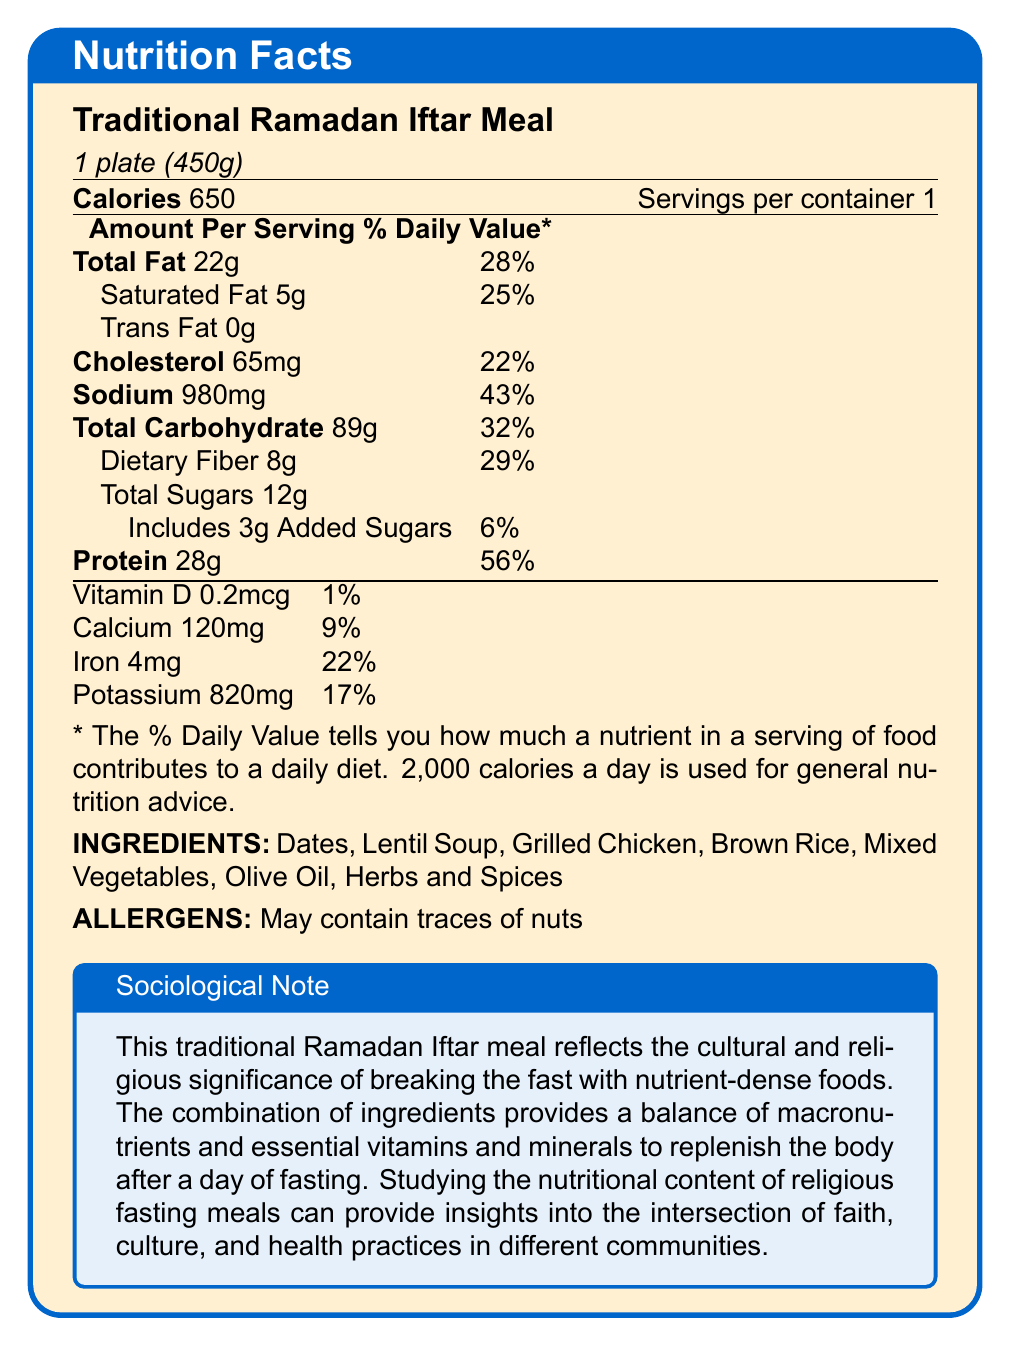what is the serving size? The serving size is clearly mentioned at the beginning of the document as "1 plate (450g)".
Answer: 1 plate (450g) how many servings are there per container? The document states that there is 1 serving per container.
Answer: 1 what is the total fat content per serving? The Total Fat content per serving is mentioned as 22g.
Answer: 22 grams how much protein does one serving contain? The protein content is listed as 28g per serving.
Answer: 28 grams what are the primary ingredients in the traditional Ramadan Iftar meal? The ingredients are explicitly listed near the end of the document.
Answer: Dates, Lentil Soup, Grilled Chicken, Brown Rice, Mixed Vegetables, Olive Oil, Herbs and Spices which of the following nutrients has the highest % daily value? A. Total Fat B. Saturated Fat C. Protein The % daily value for protein is listed as 56%, which is the highest among the options given.
Answer: C. Protein how much sodium does one serving provide? The sodium content for one serving is 980mg, as stated in the document.
Answer: 980 milligrams does the meal contain any added sugars? The document lists that the meal contains 3g of added sugars with a daily value percentage of 6%.
Answer: Yes what is the % daily value of dietary fiber in this meal? The dietary fiber % daily value is shown as 29%.
Answer: 29% is there any trans fat in this meal? The document clearly states that there is 0g of trans fat.
Answer: No which nutrient contributes the least to the daily value percentage? A. Vitamin D B. Calcium C. Potassium D. Iron Vitamin D contributes 1% to the daily value, the least among the given options.
Answer: A. Vitamin D summarize the nutritional content and cultural significance of the traditional Ramadan Iftar meal. The document provides detailed nutritional information about the Traditional Ramadan Iftar Meal, including macronutrients, vitamins, and minerals, as well as ingredients and allergens. It also includes a sociological note highlighting the cultural and religious significance of the meal.
Answer: The Traditional Ramadan Iftar Meal provides a balanced intake of nutrients with 650 calories, 22g of total fat, 28g of protein, and 89g of carbohydrates. It also includes essential minerals and vitamins. Additionally, this meal underscores the cultural and religious practice of breaking the fast with nutrient-dense foods, reflecting the intersection of faith, culture, and health practices. how many grams of saturated fat are in each serving? The document lists the saturated fat content per serving as 5g.
Answer: 5 grams what is the combined amount of total sugars and added sugars in one serving? The total sugars are 12g, and added sugars are 3g, making the combined amount 15g in one serving.
Answer: 15 grams what is the main idea of the sociological note at the end of the document? The note describes the cultural and religious significance of breaking the fast with a nutrient-dense meal and reflects on how this practice intersects with health and cultural practices in different communities.
Answer: It emphasizes the cultural and religious importance of the meal in breaking the fast and its nutritional value, which provides a balanced intake of essential nutrients. what is the vitamin D content in one serving of the meal? The vitamin D content is listed as 0.2mcg per serving.
Answer: 0.2 micrograms what percentage of the daily value for iron does one serving provide? The % daily value for iron is stated to be 22% per serving.
Answer: 22% is there any information regarding the specific religious or cultural context in the document? The sociological note at the end of the document provides information on the cultural and religious context of the meal.
Answer: Yes can you determine the calorie content per gram of the meal based on this document? The document provides information on the total calories per serving but not the specific calorie content per gram.
Answer: No 